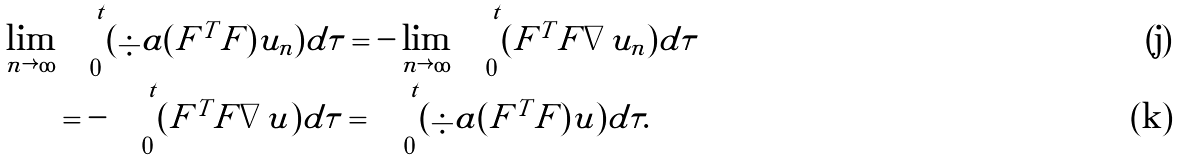<formula> <loc_0><loc_0><loc_500><loc_500>\lim _ { n \rightarrow \infty } & \int _ { 0 } ^ { t } ( \div a ( F ^ { T } F ) | \tilde { u } _ { n } ) d \tau = - \lim _ { n \rightarrow \infty } \int _ { 0 } ^ { t } ( F ^ { T } F | \nabla \tilde { u } _ { n } ) d \tau \\ & = - \int _ { 0 } ^ { t } ( F ^ { T } F | \nabla \tilde { u } ) d \tau = \int _ { 0 } ^ { t } ( \div a ( F ^ { T } F ) | \tilde { u } ) d \tau .</formula> 